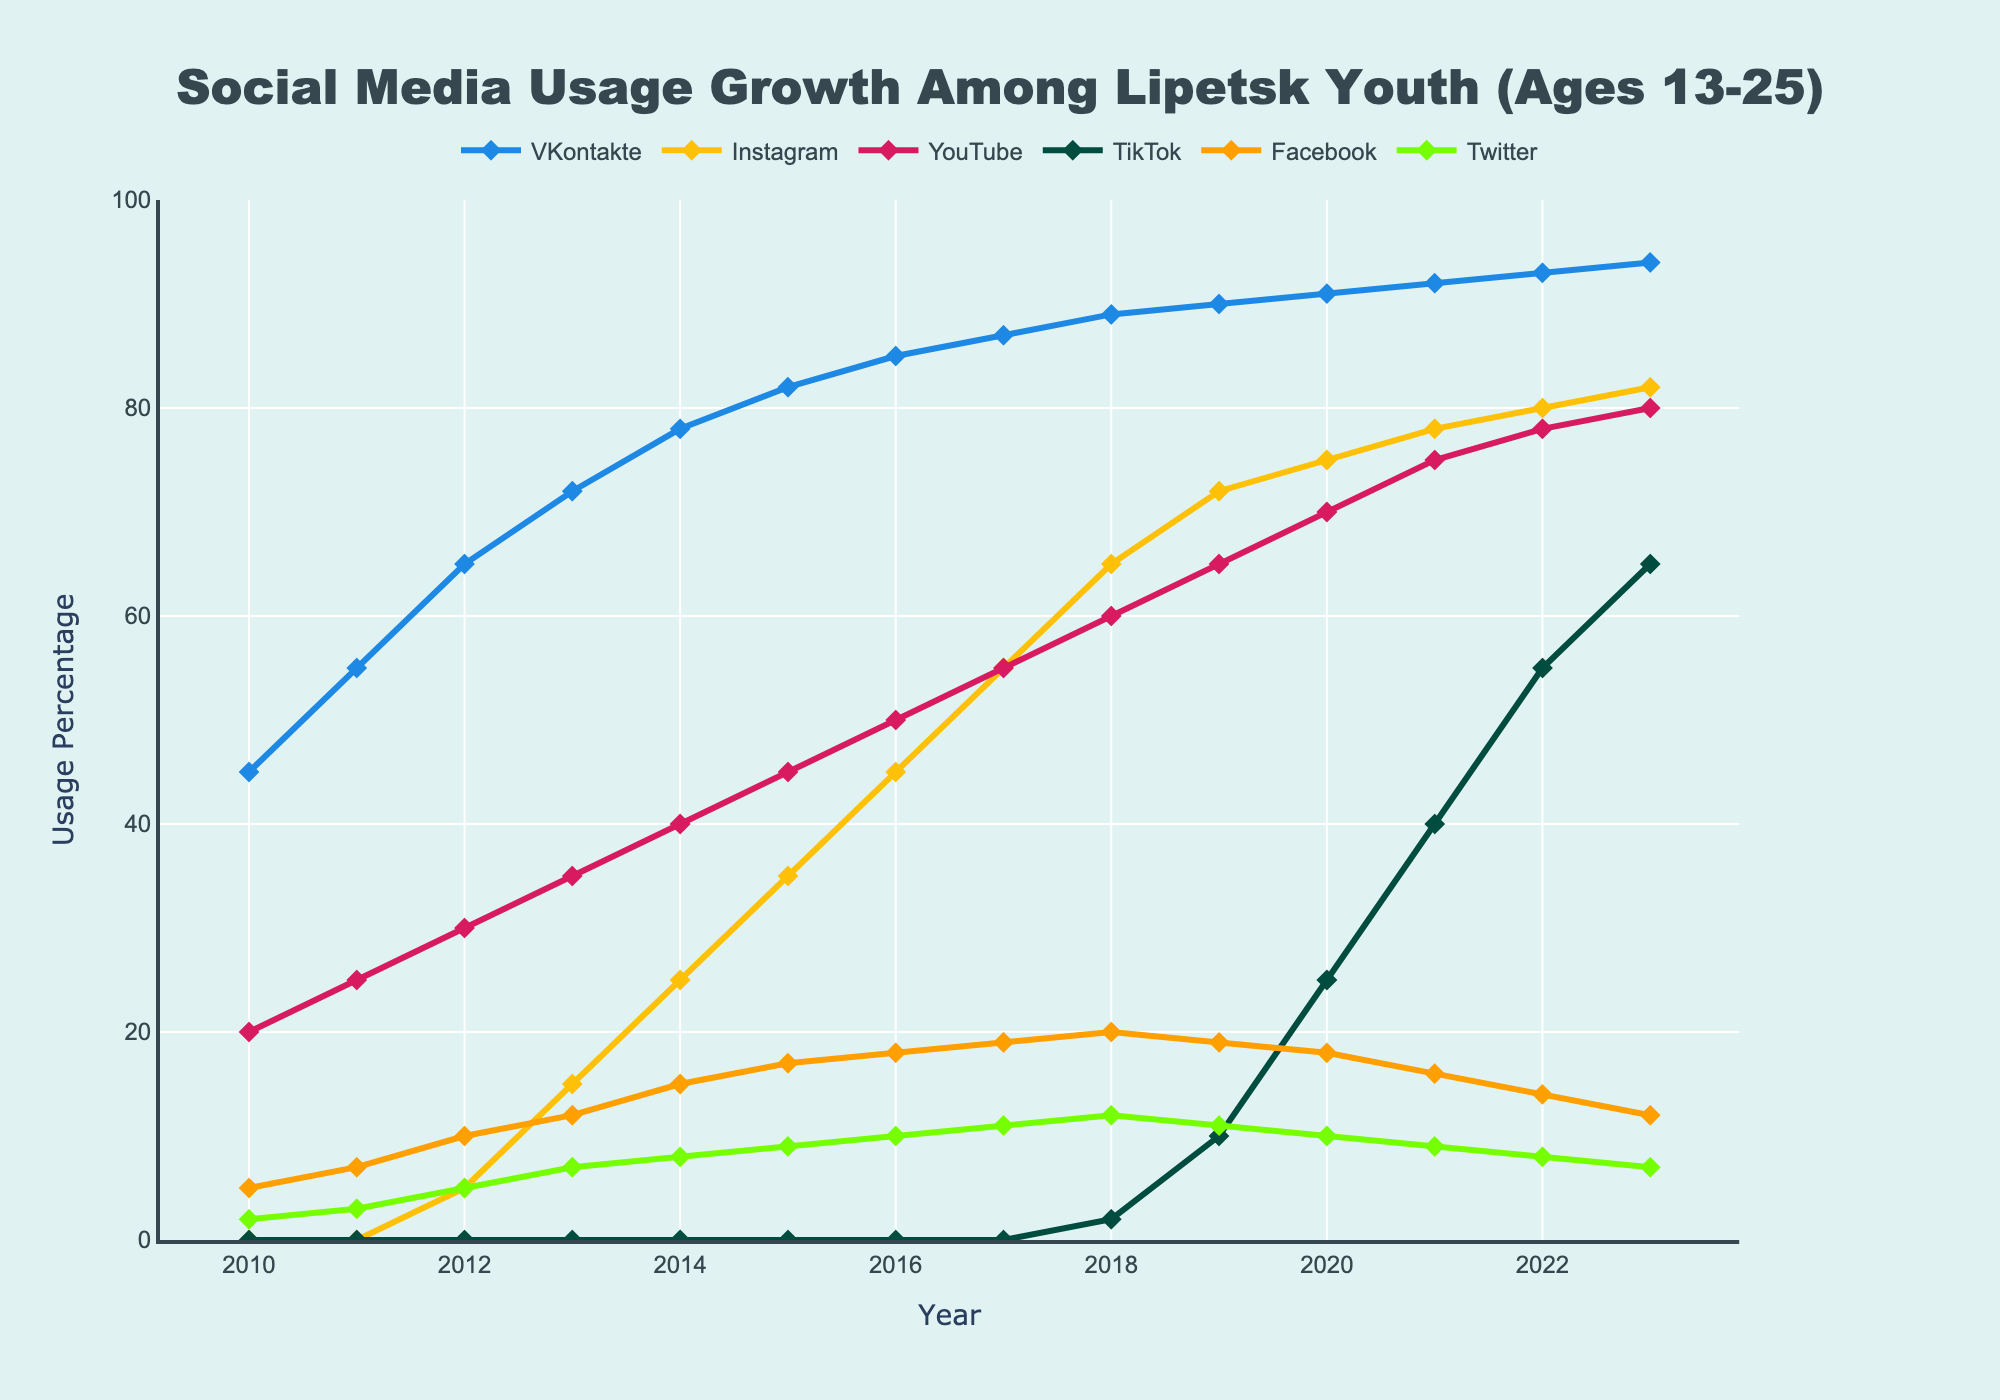Which social media platform had the highest usage percentage in 2023? By looking at the end of the lines representing different platforms in 2023, we see that VKontakte reached a usage percentage of 94, which is the highest among all platforms.
Answer: VKontakte Which year did Instagram first appear in the chart? By observing the lines, Instagram starts at 0% and first appears in 2012 with a usage percentage of 5%.
Answer: 2012 In which year did TikTok usage surpass 50%? By following the orange line (representing TikTok), it crosses the 50% mark in 2022 with a usage percentage of 55%.
Answer: 2022 What is the difference in Facebook usage between 2014 and 2015? In 2014, Facebook usage was 15%, and in 2015, it was 17%. The difference is obtained by subtracting 15 from 17.
Answer: 2% Which three social media platforms showed consistent growth each year? By examining the lines, VKontakte, Instagram, and YouTube all showed year-on-year growth from 2010 to 2023.
Answer: VKontakte, Instagram, YouTube By how much has YouTube's usage grown from 2010 to 2023? In 2010, YouTube usage was 20%, and in 2023, it was 80%. The growth is calculated by subtracting 20 from 80.
Answer: 60% Which platform experienced the most significant increase in usage between 2019 and 2020? Comparing the differences between 2019 and 2020 for each platform, TikTok had the largest increase from 10% to 25%, an increase of 15%.
Answer: TikTok What is the average usage percentage of Twitter over the observed period? Adding Twitter's usage percentages from 2010 to 2023 and dividing by the number of years (14) gives us the average. (2+3+5+7+8+9+10+11+12+11+10+9+8+7)/14 = 7.79
Answer: 7.79% When did Facebook usage peak among Lipetsk youth? By observing the Facebook line, its highest point is in 2018 with a percentage of 20%.
Answer: 2018 What was the combined usage percentage of Instagram and TikTok in 2020? In 2020, Instagram usage was 75% and TikTok was 25%. The combined percentage is obtained by adding them: 75+25=100.
Answer: 100% 